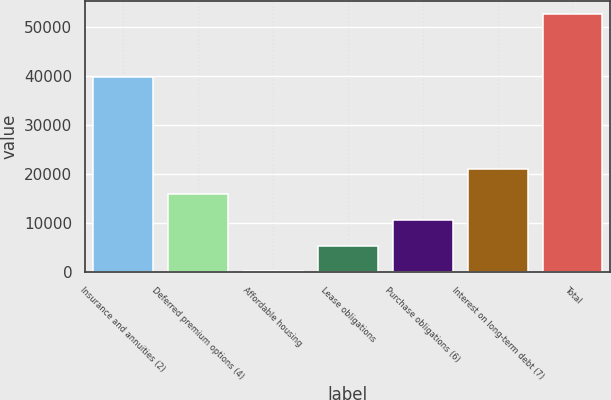Convert chart. <chart><loc_0><loc_0><loc_500><loc_500><bar_chart><fcel>Insurance and annuities (2)<fcel>Deferred premium options (4)<fcel>Affordable housing<fcel>Lease obligations<fcel>Purchase obligations (6)<fcel>Interest on long-term debt (7)<fcel>Total<nl><fcel>39849<fcel>15854<fcel>137<fcel>5376<fcel>10615<fcel>21093<fcel>52527<nl></chart> 